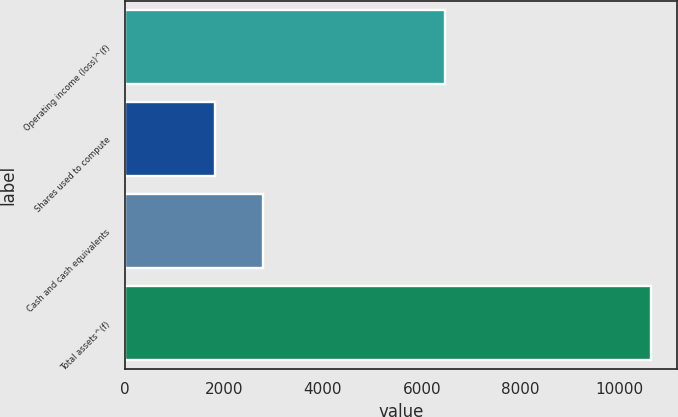Convert chart. <chart><loc_0><loc_0><loc_500><loc_500><bar_chart><fcel>Operating income (loss)^(f)<fcel>Shares used to compute<fcel>Cash and cash equivalents<fcel>Total assets^(f)<nl><fcel>6470<fcel>1811.7<fcel>2792.4<fcel>10638<nl></chart> 